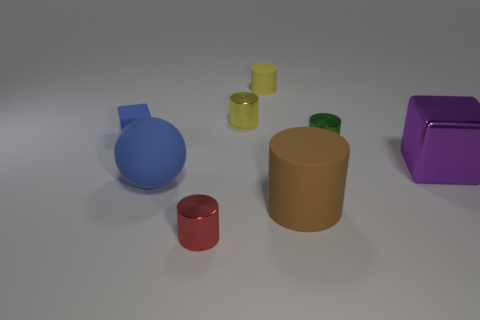There is a large rubber object that is behind the brown cylinder; is its shape the same as the green object?
Your answer should be very brief. No. Are there any matte cubes of the same size as the green metal thing?
Make the answer very short. Yes. There is a tiny yellow rubber thing; is it the same shape as the object that is left of the blue matte sphere?
Provide a short and direct response. No. There is a small matte thing that is the same color as the large matte sphere; what shape is it?
Ensure brevity in your answer.  Cube. Are there fewer blue cubes that are left of the yellow metallic cylinder than large brown cylinders?
Your response must be concise. No. Is the big purple thing the same shape as the tiny blue thing?
Offer a terse response. Yes. There is a blue block that is made of the same material as the large brown object; what is its size?
Your answer should be compact. Small. Is the number of green rubber cubes less than the number of brown things?
Offer a terse response. Yes. What number of large objects are green things or green matte objects?
Provide a succinct answer. 0. How many objects are both on the right side of the large brown thing and in front of the large brown thing?
Your answer should be very brief. 0. 